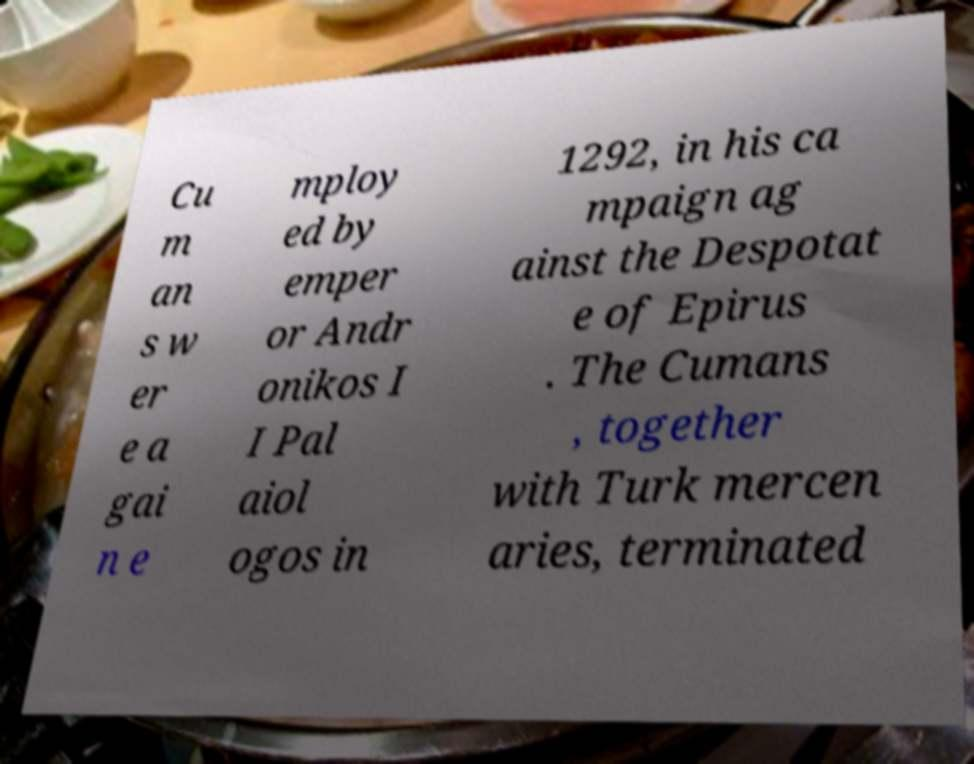Please read and relay the text visible in this image. What does it say? Cu m an s w er e a gai n e mploy ed by emper or Andr onikos I I Pal aiol ogos in 1292, in his ca mpaign ag ainst the Despotat e of Epirus . The Cumans , together with Turk mercen aries, terminated 